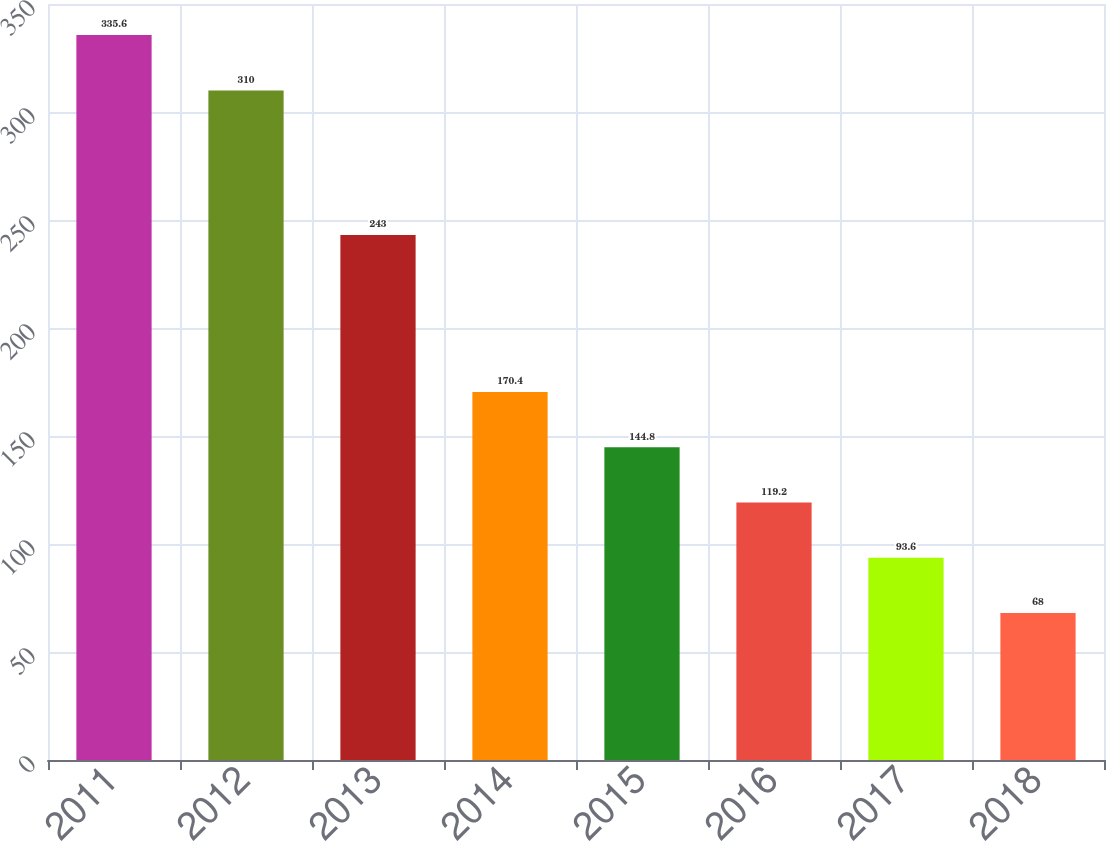Convert chart to OTSL. <chart><loc_0><loc_0><loc_500><loc_500><bar_chart><fcel>2011<fcel>2012<fcel>2013<fcel>2014<fcel>2015<fcel>2016<fcel>2017<fcel>2018<nl><fcel>335.6<fcel>310<fcel>243<fcel>170.4<fcel>144.8<fcel>119.2<fcel>93.6<fcel>68<nl></chart> 